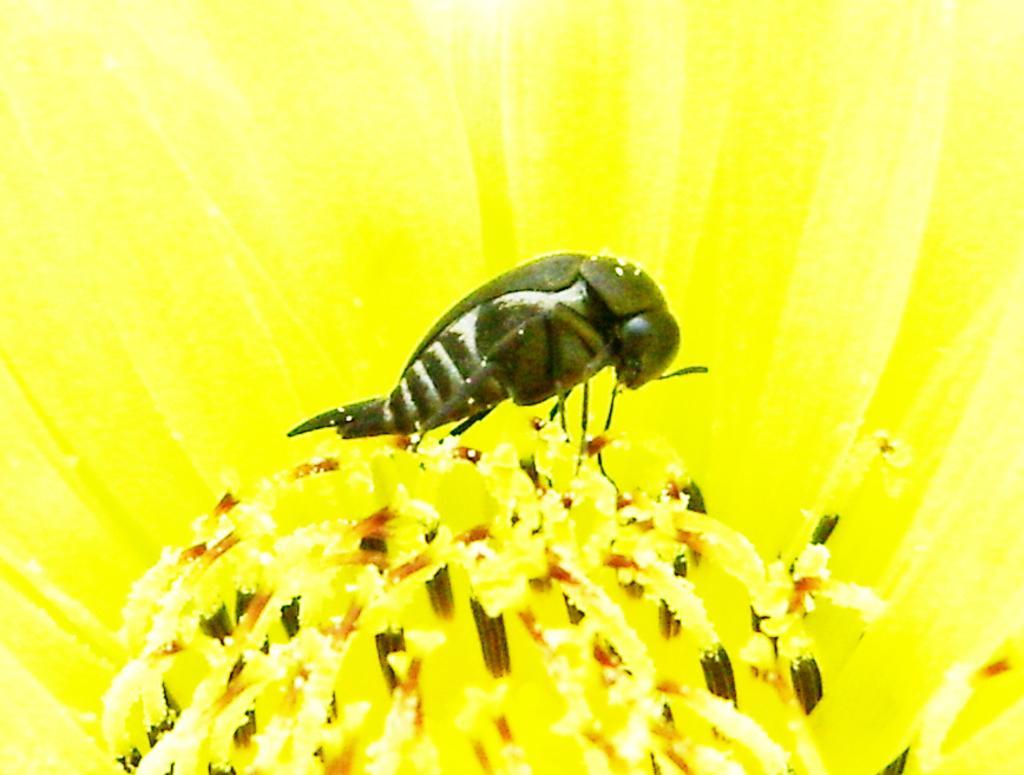Please provide a concise description of this image. In this image we can see an insect on the flower. 